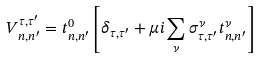<formula> <loc_0><loc_0><loc_500><loc_500>V _ { n , n ^ { \prime } } ^ { \tau , \tau ^ { \prime } } = t _ { n , n ^ { \prime } } ^ { 0 } \left [ \delta _ { \tau , \tau ^ { \prime } } + \mu i \sum _ { \nu } \sigma _ { \tau , \tau ^ { \prime } } ^ { \nu } t _ { n , n ^ { \prime } } ^ { \nu } \right ]</formula> 